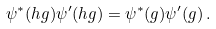<formula> <loc_0><loc_0><loc_500><loc_500>\psi ^ { * } ( h g ) \psi ^ { \prime } ( h g ) = \psi ^ { * } ( g ) \psi ^ { \prime } ( g ) \, .</formula> 